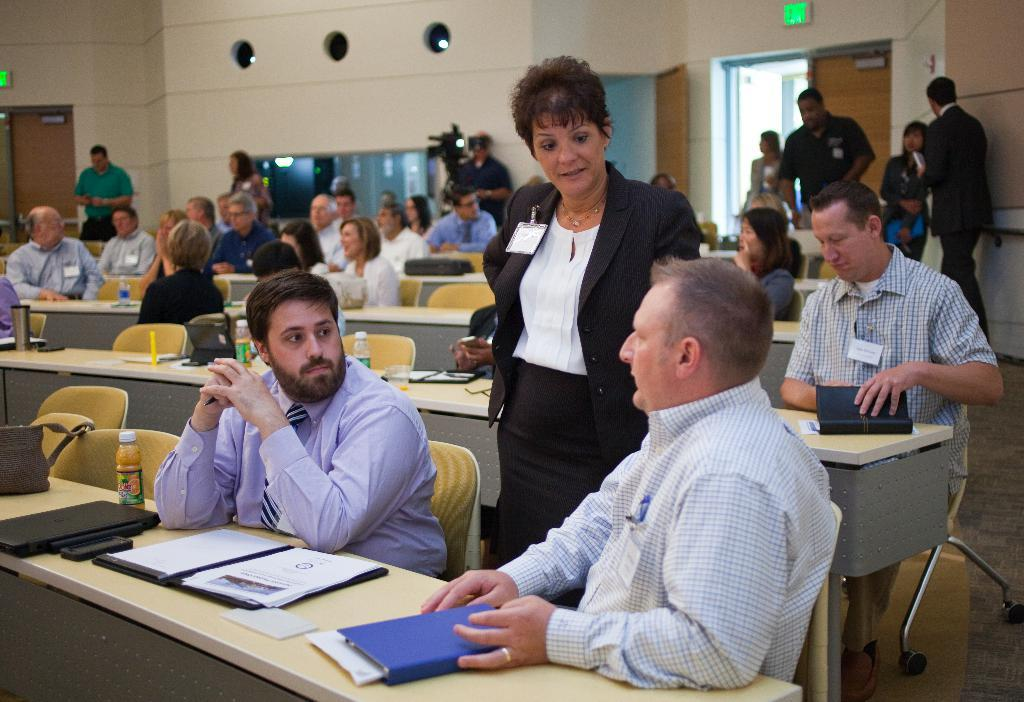What are the people in the image doing? There is a group of people sitting on chairs. What objects can be seen on the table in the image? There is a file, a bottle, and a bag on the table. Is there any equipment visible in the background of the image? Yes, there is a camera visible in the background. What type of dinner is being served in the image? There is no dinner present in the image; it features a group of people sitting on chairs and objects on a table. How does the camera stop the volleyball game in the image? There is no volleyball game present in the image, and the camera is only a background detail. 